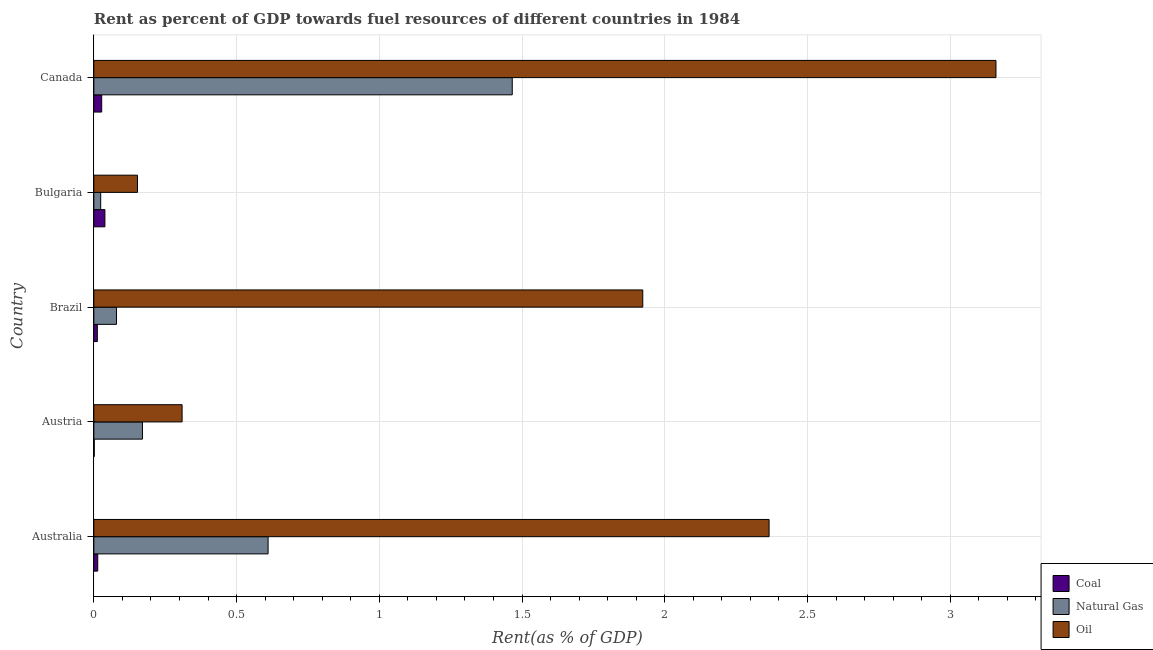How many different coloured bars are there?
Your answer should be very brief. 3. How many groups of bars are there?
Your answer should be very brief. 5. Are the number of bars per tick equal to the number of legend labels?
Provide a succinct answer. Yes. What is the label of the 1st group of bars from the top?
Provide a short and direct response. Canada. In how many cases, is the number of bars for a given country not equal to the number of legend labels?
Make the answer very short. 0. What is the rent towards coal in Bulgaria?
Ensure brevity in your answer.  0.04. Across all countries, what is the maximum rent towards natural gas?
Offer a terse response. 1.47. Across all countries, what is the minimum rent towards coal?
Offer a very short reply. 0. What is the total rent towards natural gas in the graph?
Keep it short and to the point. 2.35. What is the difference between the rent towards coal in Bulgaria and that in Canada?
Provide a short and direct response. 0.01. What is the difference between the rent towards coal in Bulgaria and the rent towards natural gas in Australia?
Your answer should be very brief. -0.57. What is the average rent towards oil per country?
Your answer should be compact. 1.58. What is the difference between the rent towards natural gas and rent towards coal in Australia?
Make the answer very short. 0.6. What is the ratio of the rent towards natural gas in Brazil to that in Canada?
Your response must be concise. 0.05. Is the rent towards coal in Austria less than that in Bulgaria?
Ensure brevity in your answer.  Yes. Is the difference between the rent towards coal in Austria and Bulgaria greater than the difference between the rent towards oil in Austria and Bulgaria?
Offer a terse response. No. What is the difference between the highest and the second highest rent towards coal?
Your response must be concise. 0.01. What is the difference between the highest and the lowest rent towards oil?
Keep it short and to the point. 3.01. What does the 1st bar from the top in Canada represents?
Provide a succinct answer. Oil. What does the 2nd bar from the bottom in Canada represents?
Make the answer very short. Natural Gas. Are the values on the major ticks of X-axis written in scientific E-notation?
Offer a very short reply. No. Does the graph contain any zero values?
Your response must be concise. No. Does the graph contain grids?
Make the answer very short. Yes. How are the legend labels stacked?
Your answer should be compact. Vertical. What is the title of the graph?
Your answer should be compact. Rent as percent of GDP towards fuel resources of different countries in 1984. Does "Errors" appear as one of the legend labels in the graph?
Provide a succinct answer. No. What is the label or title of the X-axis?
Offer a very short reply. Rent(as % of GDP). What is the label or title of the Y-axis?
Your answer should be compact. Country. What is the Rent(as % of GDP) in Coal in Australia?
Provide a succinct answer. 0.01. What is the Rent(as % of GDP) in Natural Gas in Australia?
Offer a very short reply. 0.61. What is the Rent(as % of GDP) in Oil in Australia?
Keep it short and to the point. 2.37. What is the Rent(as % of GDP) in Coal in Austria?
Keep it short and to the point. 0. What is the Rent(as % of GDP) of Natural Gas in Austria?
Provide a short and direct response. 0.17. What is the Rent(as % of GDP) in Oil in Austria?
Offer a very short reply. 0.31. What is the Rent(as % of GDP) in Coal in Brazil?
Offer a very short reply. 0.01. What is the Rent(as % of GDP) in Natural Gas in Brazil?
Provide a succinct answer. 0.08. What is the Rent(as % of GDP) in Oil in Brazil?
Keep it short and to the point. 1.92. What is the Rent(as % of GDP) in Coal in Bulgaria?
Provide a succinct answer. 0.04. What is the Rent(as % of GDP) in Natural Gas in Bulgaria?
Your response must be concise. 0.02. What is the Rent(as % of GDP) of Oil in Bulgaria?
Your answer should be compact. 0.15. What is the Rent(as % of GDP) of Coal in Canada?
Offer a terse response. 0.03. What is the Rent(as % of GDP) of Natural Gas in Canada?
Ensure brevity in your answer.  1.47. What is the Rent(as % of GDP) in Oil in Canada?
Your answer should be very brief. 3.16. Across all countries, what is the maximum Rent(as % of GDP) in Coal?
Your answer should be very brief. 0.04. Across all countries, what is the maximum Rent(as % of GDP) of Natural Gas?
Make the answer very short. 1.47. Across all countries, what is the maximum Rent(as % of GDP) of Oil?
Your answer should be very brief. 3.16. Across all countries, what is the minimum Rent(as % of GDP) in Coal?
Ensure brevity in your answer.  0. Across all countries, what is the minimum Rent(as % of GDP) of Natural Gas?
Your answer should be compact. 0.02. Across all countries, what is the minimum Rent(as % of GDP) of Oil?
Provide a succinct answer. 0.15. What is the total Rent(as % of GDP) of Coal in the graph?
Keep it short and to the point. 0.09. What is the total Rent(as % of GDP) of Natural Gas in the graph?
Offer a terse response. 2.35. What is the total Rent(as % of GDP) of Oil in the graph?
Your answer should be compact. 7.91. What is the difference between the Rent(as % of GDP) in Coal in Australia and that in Austria?
Make the answer very short. 0.01. What is the difference between the Rent(as % of GDP) in Natural Gas in Australia and that in Austria?
Your answer should be compact. 0.44. What is the difference between the Rent(as % of GDP) of Oil in Australia and that in Austria?
Keep it short and to the point. 2.06. What is the difference between the Rent(as % of GDP) in Coal in Australia and that in Brazil?
Offer a very short reply. 0. What is the difference between the Rent(as % of GDP) in Natural Gas in Australia and that in Brazil?
Ensure brevity in your answer.  0.53. What is the difference between the Rent(as % of GDP) in Oil in Australia and that in Brazil?
Your response must be concise. 0.44. What is the difference between the Rent(as % of GDP) of Coal in Australia and that in Bulgaria?
Provide a short and direct response. -0.03. What is the difference between the Rent(as % of GDP) of Natural Gas in Australia and that in Bulgaria?
Provide a short and direct response. 0.59. What is the difference between the Rent(as % of GDP) of Oil in Australia and that in Bulgaria?
Ensure brevity in your answer.  2.21. What is the difference between the Rent(as % of GDP) in Coal in Australia and that in Canada?
Give a very brief answer. -0.01. What is the difference between the Rent(as % of GDP) of Natural Gas in Australia and that in Canada?
Your answer should be compact. -0.86. What is the difference between the Rent(as % of GDP) in Oil in Australia and that in Canada?
Ensure brevity in your answer.  -0.79. What is the difference between the Rent(as % of GDP) in Coal in Austria and that in Brazil?
Your answer should be very brief. -0.01. What is the difference between the Rent(as % of GDP) in Natural Gas in Austria and that in Brazil?
Keep it short and to the point. 0.09. What is the difference between the Rent(as % of GDP) in Oil in Austria and that in Brazil?
Your response must be concise. -1.61. What is the difference between the Rent(as % of GDP) of Coal in Austria and that in Bulgaria?
Provide a succinct answer. -0.04. What is the difference between the Rent(as % of GDP) of Natural Gas in Austria and that in Bulgaria?
Your answer should be compact. 0.15. What is the difference between the Rent(as % of GDP) of Oil in Austria and that in Bulgaria?
Make the answer very short. 0.16. What is the difference between the Rent(as % of GDP) of Coal in Austria and that in Canada?
Ensure brevity in your answer.  -0.03. What is the difference between the Rent(as % of GDP) of Natural Gas in Austria and that in Canada?
Offer a terse response. -1.3. What is the difference between the Rent(as % of GDP) in Oil in Austria and that in Canada?
Provide a short and direct response. -2.85. What is the difference between the Rent(as % of GDP) of Coal in Brazil and that in Bulgaria?
Provide a short and direct response. -0.03. What is the difference between the Rent(as % of GDP) in Natural Gas in Brazil and that in Bulgaria?
Provide a short and direct response. 0.06. What is the difference between the Rent(as % of GDP) of Oil in Brazil and that in Bulgaria?
Provide a short and direct response. 1.77. What is the difference between the Rent(as % of GDP) of Coal in Brazil and that in Canada?
Your response must be concise. -0.02. What is the difference between the Rent(as % of GDP) of Natural Gas in Brazil and that in Canada?
Keep it short and to the point. -1.39. What is the difference between the Rent(as % of GDP) in Oil in Brazil and that in Canada?
Provide a short and direct response. -1.24. What is the difference between the Rent(as % of GDP) of Coal in Bulgaria and that in Canada?
Your response must be concise. 0.01. What is the difference between the Rent(as % of GDP) in Natural Gas in Bulgaria and that in Canada?
Your answer should be very brief. -1.44. What is the difference between the Rent(as % of GDP) of Oil in Bulgaria and that in Canada?
Offer a terse response. -3.01. What is the difference between the Rent(as % of GDP) of Coal in Australia and the Rent(as % of GDP) of Natural Gas in Austria?
Your answer should be compact. -0.16. What is the difference between the Rent(as % of GDP) in Coal in Australia and the Rent(as % of GDP) in Oil in Austria?
Your answer should be very brief. -0.3. What is the difference between the Rent(as % of GDP) in Natural Gas in Australia and the Rent(as % of GDP) in Oil in Austria?
Give a very brief answer. 0.3. What is the difference between the Rent(as % of GDP) in Coal in Australia and the Rent(as % of GDP) in Natural Gas in Brazil?
Your answer should be very brief. -0.07. What is the difference between the Rent(as % of GDP) of Coal in Australia and the Rent(as % of GDP) of Oil in Brazil?
Your answer should be very brief. -1.91. What is the difference between the Rent(as % of GDP) of Natural Gas in Australia and the Rent(as % of GDP) of Oil in Brazil?
Give a very brief answer. -1.31. What is the difference between the Rent(as % of GDP) of Coal in Australia and the Rent(as % of GDP) of Natural Gas in Bulgaria?
Make the answer very short. -0.01. What is the difference between the Rent(as % of GDP) in Coal in Australia and the Rent(as % of GDP) in Oil in Bulgaria?
Provide a succinct answer. -0.14. What is the difference between the Rent(as % of GDP) of Natural Gas in Australia and the Rent(as % of GDP) of Oil in Bulgaria?
Provide a succinct answer. 0.46. What is the difference between the Rent(as % of GDP) of Coal in Australia and the Rent(as % of GDP) of Natural Gas in Canada?
Your answer should be compact. -1.45. What is the difference between the Rent(as % of GDP) in Coal in Australia and the Rent(as % of GDP) in Oil in Canada?
Provide a succinct answer. -3.15. What is the difference between the Rent(as % of GDP) in Natural Gas in Australia and the Rent(as % of GDP) in Oil in Canada?
Offer a very short reply. -2.55. What is the difference between the Rent(as % of GDP) in Coal in Austria and the Rent(as % of GDP) in Natural Gas in Brazil?
Give a very brief answer. -0.08. What is the difference between the Rent(as % of GDP) of Coal in Austria and the Rent(as % of GDP) of Oil in Brazil?
Give a very brief answer. -1.92. What is the difference between the Rent(as % of GDP) of Natural Gas in Austria and the Rent(as % of GDP) of Oil in Brazil?
Ensure brevity in your answer.  -1.75. What is the difference between the Rent(as % of GDP) of Coal in Austria and the Rent(as % of GDP) of Natural Gas in Bulgaria?
Provide a succinct answer. -0.02. What is the difference between the Rent(as % of GDP) of Coal in Austria and the Rent(as % of GDP) of Oil in Bulgaria?
Provide a short and direct response. -0.15. What is the difference between the Rent(as % of GDP) in Natural Gas in Austria and the Rent(as % of GDP) in Oil in Bulgaria?
Your answer should be very brief. 0.02. What is the difference between the Rent(as % of GDP) of Coal in Austria and the Rent(as % of GDP) of Natural Gas in Canada?
Provide a short and direct response. -1.46. What is the difference between the Rent(as % of GDP) in Coal in Austria and the Rent(as % of GDP) in Oil in Canada?
Offer a terse response. -3.16. What is the difference between the Rent(as % of GDP) of Natural Gas in Austria and the Rent(as % of GDP) of Oil in Canada?
Provide a succinct answer. -2.99. What is the difference between the Rent(as % of GDP) of Coal in Brazil and the Rent(as % of GDP) of Natural Gas in Bulgaria?
Your response must be concise. -0.01. What is the difference between the Rent(as % of GDP) of Coal in Brazil and the Rent(as % of GDP) of Oil in Bulgaria?
Keep it short and to the point. -0.14. What is the difference between the Rent(as % of GDP) in Natural Gas in Brazil and the Rent(as % of GDP) in Oil in Bulgaria?
Provide a short and direct response. -0.07. What is the difference between the Rent(as % of GDP) of Coal in Brazil and the Rent(as % of GDP) of Natural Gas in Canada?
Your answer should be compact. -1.45. What is the difference between the Rent(as % of GDP) of Coal in Brazil and the Rent(as % of GDP) of Oil in Canada?
Your answer should be compact. -3.15. What is the difference between the Rent(as % of GDP) in Natural Gas in Brazil and the Rent(as % of GDP) in Oil in Canada?
Keep it short and to the point. -3.08. What is the difference between the Rent(as % of GDP) in Coal in Bulgaria and the Rent(as % of GDP) in Natural Gas in Canada?
Your answer should be compact. -1.43. What is the difference between the Rent(as % of GDP) of Coal in Bulgaria and the Rent(as % of GDP) of Oil in Canada?
Your answer should be compact. -3.12. What is the difference between the Rent(as % of GDP) of Natural Gas in Bulgaria and the Rent(as % of GDP) of Oil in Canada?
Your response must be concise. -3.14. What is the average Rent(as % of GDP) of Coal per country?
Ensure brevity in your answer.  0.02. What is the average Rent(as % of GDP) in Natural Gas per country?
Keep it short and to the point. 0.47. What is the average Rent(as % of GDP) of Oil per country?
Ensure brevity in your answer.  1.58. What is the difference between the Rent(as % of GDP) of Coal and Rent(as % of GDP) of Natural Gas in Australia?
Provide a short and direct response. -0.6. What is the difference between the Rent(as % of GDP) in Coal and Rent(as % of GDP) in Oil in Australia?
Ensure brevity in your answer.  -2.35. What is the difference between the Rent(as % of GDP) in Natural Gas and Rent(as % of GDP) in Oil in Australia?
Offer a very short reply. -1.75. What is the difference between the Rent(as % of GDP) in Coal and Rent(as % of GDP) in Natural Gas in Austria?
Your answer should be compact. -0.17. What is the difference between the Rent(as % of GDP) in Coal and Rent(as % of GDP) in Oil in Austria?
Give a very brief answer. -0.31. What is the difference between the Rent(as % of GDP) in Natural Gas and Rent(as % of GDP) in Oil in Austria?
Your answer should be compact. -0.14. What is the difference between the Rent(as % of GDP) in Coal and Rent(as % of GDP) in Natural Gas in Brazil?
Offer a terse response. -0.07. What is the difference between the Rent(as % of GDP) of Coal and Rent(as % of GDP) of Oil in Brazil?
Your answer should be compact. -1.91. What is the difference between the Rent(as % of GDP) in Natural Gas and Rent(as % of GDP) in Oil in Brazil?
Provide a short and direct response. -1.84. What is the difference between the Rent(as % of GDP) in Coal and Rent(as % of GDP) in Natural Gas in Bulgaria?
Give a very brief answer. 0.01. What is the difference between the Rent(as % of GDP) of Coal and Rent(as % of GDP) of Oil in Bulgaria?
Your answer should be compact. -0.11. What is the difference between the Rent(as % of GDP) in Natural Gas and Rent(as % of GDP) in Oil in Bulgaria?
Your response must be concise. -0.13. What is the difference between the Rent(as % of GDP) in Coal and Rent(as % of GDP) in Natural Gas in Canada?
Ensure brevity in your answer.  -1.44. What is the difference between the Rent(as % of GDP) of Coal and Rent(as % of GDP) of Oil in Canada?
Make the answer very short. -3.13. What is the difference between the Rent(as % of GDP) in Natural Gas and Rent(as % of GDP) in Oil in Canada?
Your response must be concise. -1.69. What is the ratio of the Rent(as % of GDP) of Coal in Australia to that in Austria?
Offer a very short reply. 8.91. What is the ratio of the Rent(as % of GDP) of Natural Gas in Australia to that in Austria?
Offer a very short reply. 3.58. What is the ratio of the Rent(as % of GDP) in Oil in Australia to that in Austria?
Provide a succinct answer. 7.65. What is the ratio of the Rent(as % of GDP) of Coal in Australia to that in Brazil?
Provide a short and direct response. 1.11. What is the ratio of the Rent(as % of GDP) of Natural Gas in Australia to that in Brazil?
Provide a short and direct response. 7.69. What is the ratio of the Rent(as % of GDP) of Oil in Australia to that in Brazil?
Give a very brief answer. 1.23. What is the ratio of the Rent(as % of GDP) of Coal in Australia to that in Bulgaria?
Give a very brief answer. 0.35. What is the ratio of the Rent(as % of GDP) in Natural Gas in Australia to that in Bulgaria?
Provide a short and direct response. 25.39. What is the ratio of the Rent(as % of GDP) of Oil in Australia to that in Bulgaria?
Keep it short and to the point. 15.47. What is the ratio of the Rent(as % of GDP) of Coal in Australia to that in Canada?
Provide a short and direct response. 0.5. What is the ratio of the Rent(as % of GDP) in Natural Gas in Australia to that in Canada?
Your answer should be compact. 0.42. What is the ratio of the Rent(as % of GDP) of Oil in Australia to that in Canada?
Offer a very short reply. 0.75. What is the ratio of the Rent(as % of GDP) in Coal in Austria to that in Brazil?
Keep it short and to the point. 0.12. What is the ratio of the Rent(as % of GDP) of Natural Gas in Austria to that in Brazil?
Ensure brevity in your answer.  2.15. What is the ratio of the Rent(as % of GDP) of Oil in Austria to that in Brazil?
Your response must be concise. 0.16. What is the ratio of the Rent(as % of GDP) in Coal in Austria to that in Bulgaria?
Keep it short and to the point. 0.04. What is the ratio of the Rent(as % of GDP) of Natural Gas in Austria to that in Bulgaria?
Provide a succinct answer. 7.08. What is the ratio of the Rent(as % of GDP) in Oil in Austria to that in Bulgaria?
Keep it short and to the point. 2.02. What is the ratio of the Rent(as % of GDP) in Coal in Austria to that in Canada?
Give a very brief answer. 0.06. What is the ratio of the Rent(as % of GDP) of Natural Gas in Austria to that in Canada?
Your response must be concise. 0.12. What is the ratio of the Rent(as % of GDP) in Oil in Austria to that in Canada?
Offer a very short reply. 0.1. What is the ratio of the Rent(as % of GDP) in Coal in Brazil to that in Bulgaria?
Your answer should be compact. 0.32. What is the ratio of the Rent(as % of GDP) of Natural Gas in Brazil to that in Bulgaria?
Your answer should be very brief. 3.3. What is the ratio of the Rent(as % of GDP) in Oil in Brazil to that in Bulgaria?
Give a very brief answer. 12.57. What is the ratio of the Rent(as % of GDP) in Coal in Brazil to that in Canada?
Provide a succinct answer. 0.45. What is the ratio of the Rent(as % of GDP) in Natural Gas in Brazil to that in Canada?
Provide a succinct answer. 0.05. What is the ratio of the Rent(as % of GDP) in Oil in Brazil to that in Canada?
Your answer should be compact. 0.61. What is the ratio of the Rent(as % of GDP) of Coal in Bulgaria to that in Canada?
Keep it short and to the point. 1.41. What is the ratio of the Rent(as % of GDP) in Natural Gas in Bulgaria to that in Canada?
Ensure brevity in your answer.  0.02. What is the ratio of the Rent(as % of GDP) of Oil in Bulgaria to that in Canada?
Make the answer very short. 0.05. What is the difference between the highest and the second highest Rent(as % of GDP) in Coal?
Provide a succinct answer. 0.01. What is the difference between the highest and the second highest Rent(as % of GDP) in Natural Gas?
Your answer should be compact. 0.86. What is the difference between the highest and the second highest Rent(as % of GDP) in Oil?
Keep it short and to the point. 0.79. What is the difference between the highest and the lowest Rent(as % of GDP) in Coal?
Provide a short and direct response. 0.04. What is the difference between the highest and the lowest Rent(as % of GDP) of Natural Gas?
Offer a terse response. 1.44. What is the difference between the highest and the lowest Rent(as % of GDP) of Oil?
Offer a terse response. 3.01. 